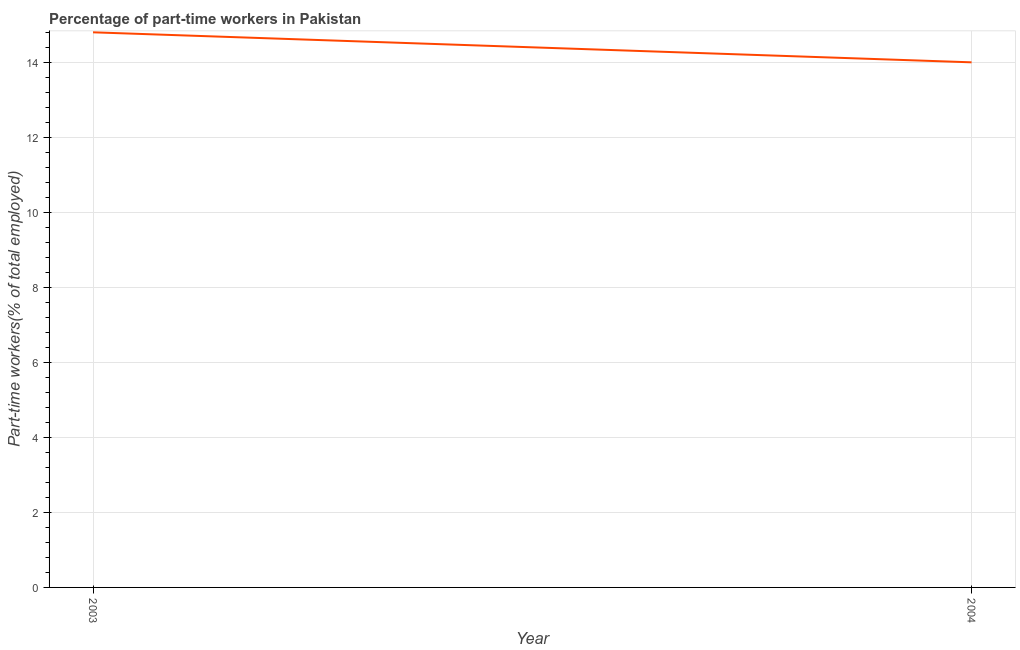Across all years, what is the maximum percentage of part-time workers?
Ensure brevity in your answer.  14.8. Across all years, what is the minimum percentage of part-time workers?
Offer a terse response. 14. In which year was the percentage of part-time workers maximum?
Offer a terse response. 2003. In which year was the percentage of part-time workers minimum?
Offer a terse response. 2004. What is the sum of the percentage of part-time workers?
Offer a very short reply. 28.8. What is the difference between the percentage of part-time workers in 2003 and 2004?
Offer a very short reply. 0.8. What is the average percentage of part-time workers per year?
Offer a terse response. 14.4. What is the median percentage of part-time workers?
Provide a short and direct response. 14.4. In how many years, is the percentage of part-time workers greater than 9.6 %?
Ensure brevity in your answer.  2. What is the ratio of the percentage of part-time workers in 2003 to that in 2004?
Keep it short and to the point. 1.06. In how many years, is the percentage of part-time workers greater than the average percentage of part-time workers taken over all years?
Keep it short and to the point. 1. Does the percentage of part-time workers monotonically increase over the years?
Give a very brief answer. No. What is the difference between two consecutive major ticks on the Y-axis?
Your response must be concise. 2. Does the graph contain grids?
Keep it short and to the point. Yes. What is the title of the graph?
Your response must be concise. Percentage of part-time workers in Pakistan. What is the label or title of the Y-axis?
Give a very brief answer. Part-time workers(% of total employed). What is the Part-time workers(% of total employed) of 2003?
Your answer should be very brief. 14.8. What is the Part-time workers(% of total employed) in 2004?
Offer a terse response. 14. What is the ratio of the Part-time workers(% of total employed) in 2003 to that in 2004?
Give a very brief answer. 1.06. 